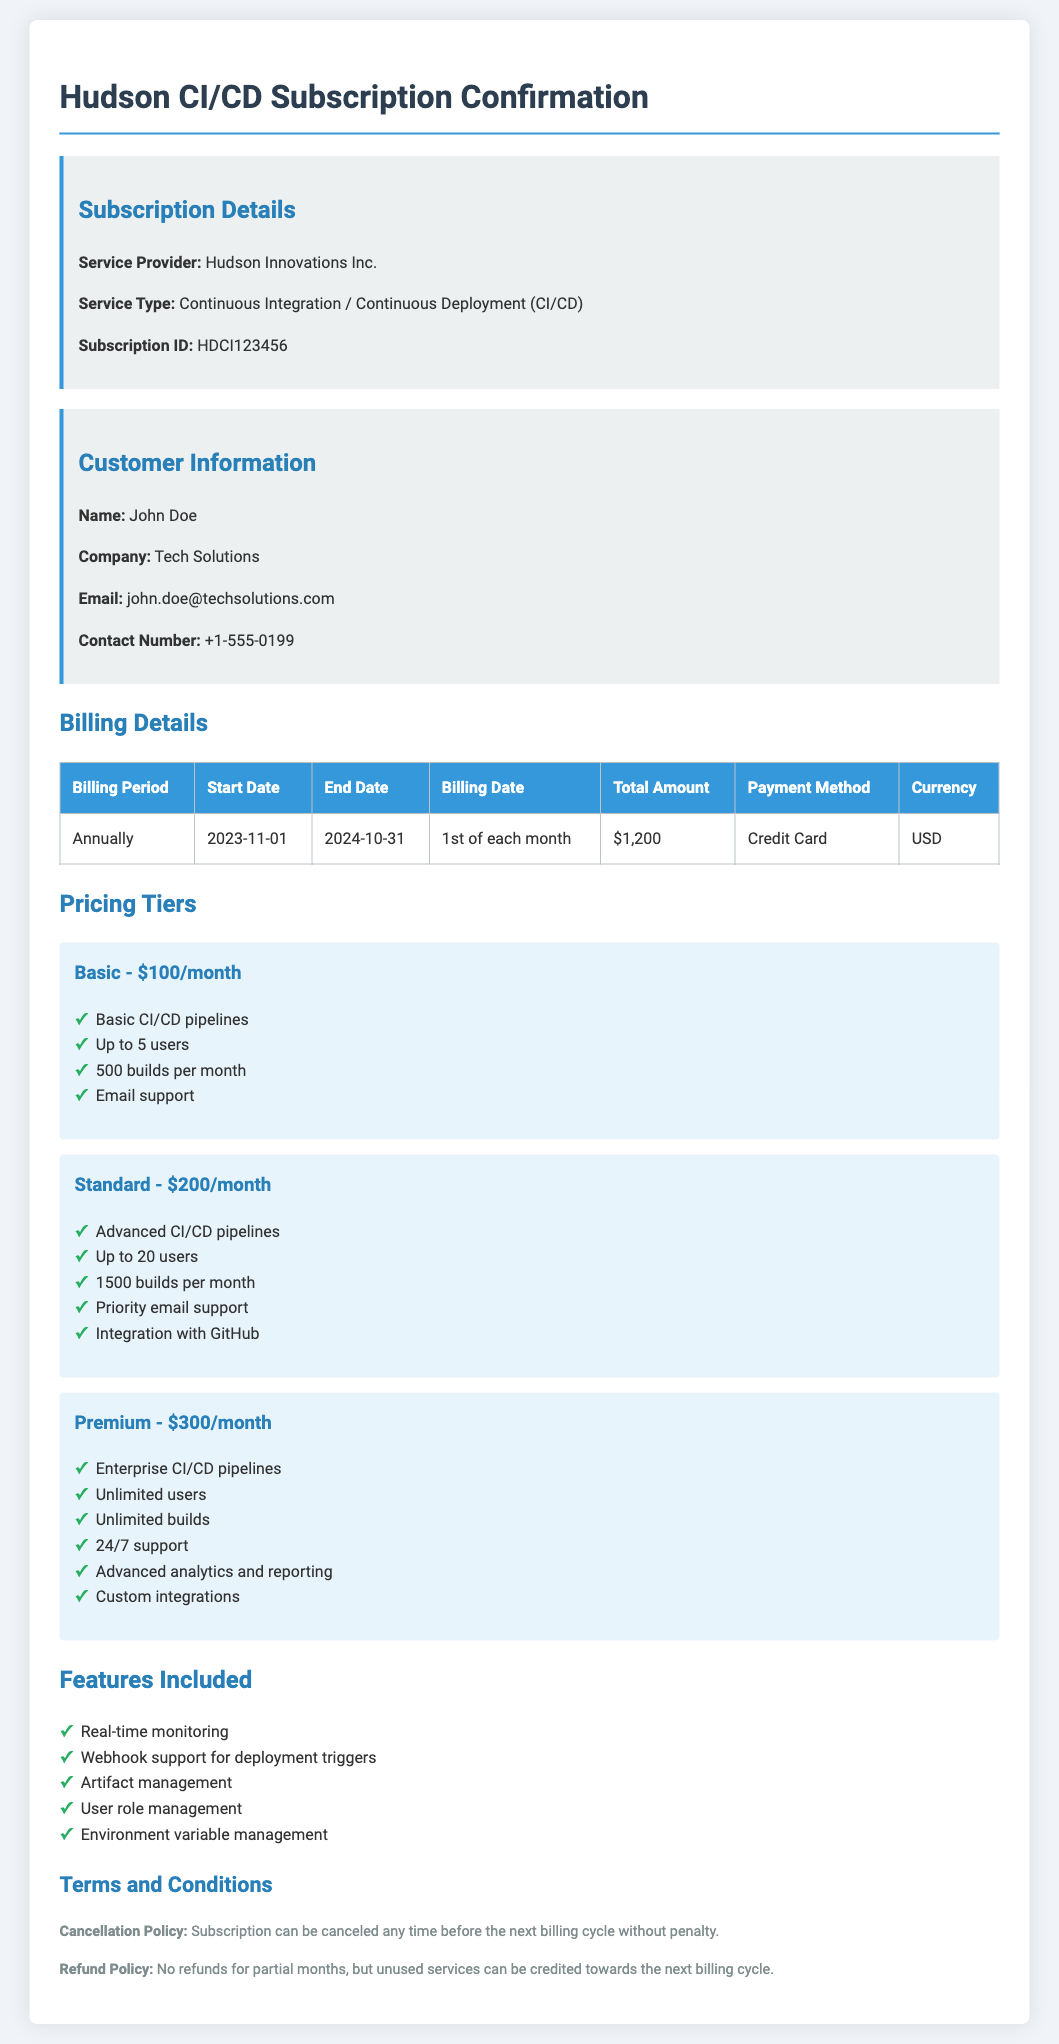What is the subscription ID? The subscription ID is specified under Subscription Details in the document.
Answer: HDCI123456 Who is the service provider? The service provider's name is mentioned in the Subscription Details section of the document.
Answer: Hudson Innovations Inc What is the start date of the billing period? The start date is listed in the billing details table.
Answer: 2023-11-01 What is the total amount for the subscription? The total amount is presented in the billing details table.
Answer: $1,200 How often is the billing period? The billing period frequency is described in the billing details section.
Answer: Annually What tier includes unlimited users? The tier names and their associated features are listed in the Pricing Tiers section.
Answer: Premium What payment method is used for the subscription? The payment method can be found in the billing details table.
Answer: Credit Card What is the cancellation policy? The cancellation policy is detailed in the Terms and Conditions section of the document.
Answer: Subscription can be canceled any time before the next billing cycle without penalty Which feature is associated with 24/7 support? The features are outlined in the Features Included section, and details can be found in the Pricing Tiers section.
Answer: Premium 